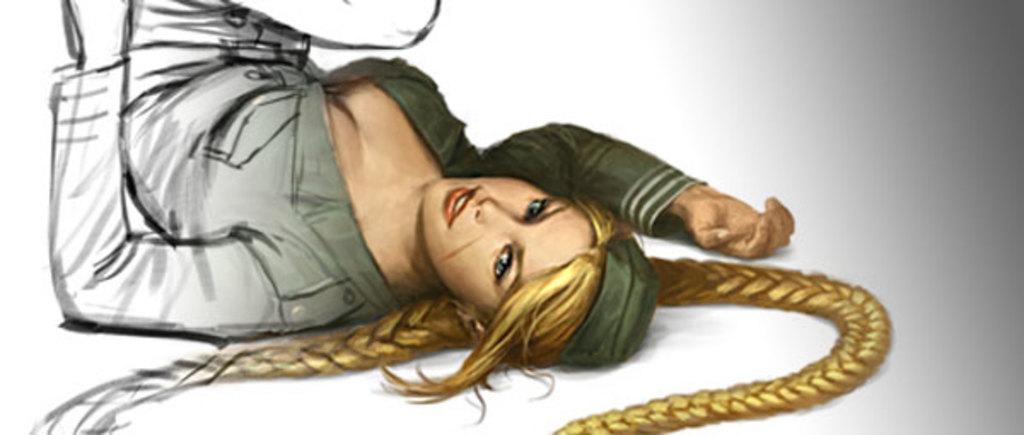How would you summarize this image in a sentence or two? In the picture we can see a cartoon image of a woman lying on the floor and she has two long hair plaits. 